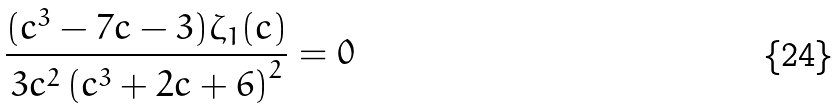<formula> <loc_0><loc_0><loc_500><loc_500>\frac { ( c ^ { 3 } - 7 c - 3 ) \zeta _ { 1 } ( c ) } { 3 c ^ { 2 } \left ( c ^ { 3 } + 2 c + 6 \right ) ^ { 2 } } = 0</formula> 